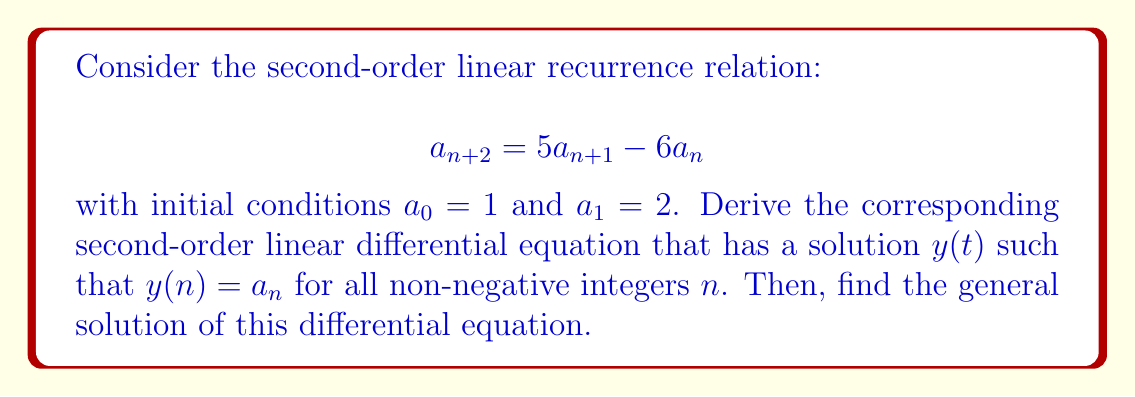Could you help me with this problem? To solve this problem, we'll follow these steps:

1) First, we need to recognize that the recurrence relation can be transformed into a differential equation by replacing the discrete sequence $a_n$ with a continuous function $y(t)$ such that $y(n) = a_n$ for all non-negative integers $n$.

2) In the recurrence relation, we replace:
   $a_n$ with $y(t)$
   $a_{n+1}$ with $y(t+1)$
   $a_{n+2}$ with $y(t+2)$

3) The recurrence relation becomes:
   $$y(t+2) = 5y(t+1) - 6y(t)$$

4) Now, we need to express $y(t+1)$ and $y(t+2)$ in terms of $y(t)$ and its derivatives. We can do this using Taylor series expansion:

   $$y(t+1) = y(t) + y'(t) + \frac{1}{2}y''(t) + \frac{1}{6}y'''(t) + ...$$
   $$y(t+2) = y(t) + 2y'(t) + 2y''(t) + \frac{4}{3}y'''(t) + ...$$

5) Substituting these into our equation:

   $$y(t) + 2y'(t) + 2y''(t) + \frac{4}{3}y'''(t) + ... = 5(y(t) + y'(t) + \frac{1}{2}y''(t) + \frac{1}{6}y'''(t) + ...) - 6y(t)$$

6) Collecting terms and ignoring higher order terms:

   $$2y''(t) + 2y'(t) - y(t) = 0$$

7) This is our desired second-order linear differential equation.

8) To find the general solution, we need to find the characteristic equation:

   $$2r^2 + 2r - 1 = 0$$

9) Solving this quadratic equation:

   $$r = \frac{-2 \pm \sqrt{4 + 8}}{4} = \frac{-2 \pm \sqrt{12}}{4} = \frac{-1 \pm \sqrt{3}}{2}$$

10) Therefore, the general solution is:

    $$y(t) = c_1e^{(\frac{-1 + \sqrt{3}}{2})t} + c_2e^{(\frac{-1 - \sqrt{3}}{2})t}$$

    where $c_1$ and $c_2$ are arbitrary constants.
Answer: The corresponding second-order linear differential equation is:

$$2y''(t) + 2y'(t) - y(t) = 0$$

And its general solution is:

$$y(t) = c_1e^{(\frac{-1 + \sqrt{3}}{2})t} + c_2e^{(\frac{-1 - \sqrt{3}}{2})t}$$

where $c_1$ and $c_2$ are arbitrary constants. 